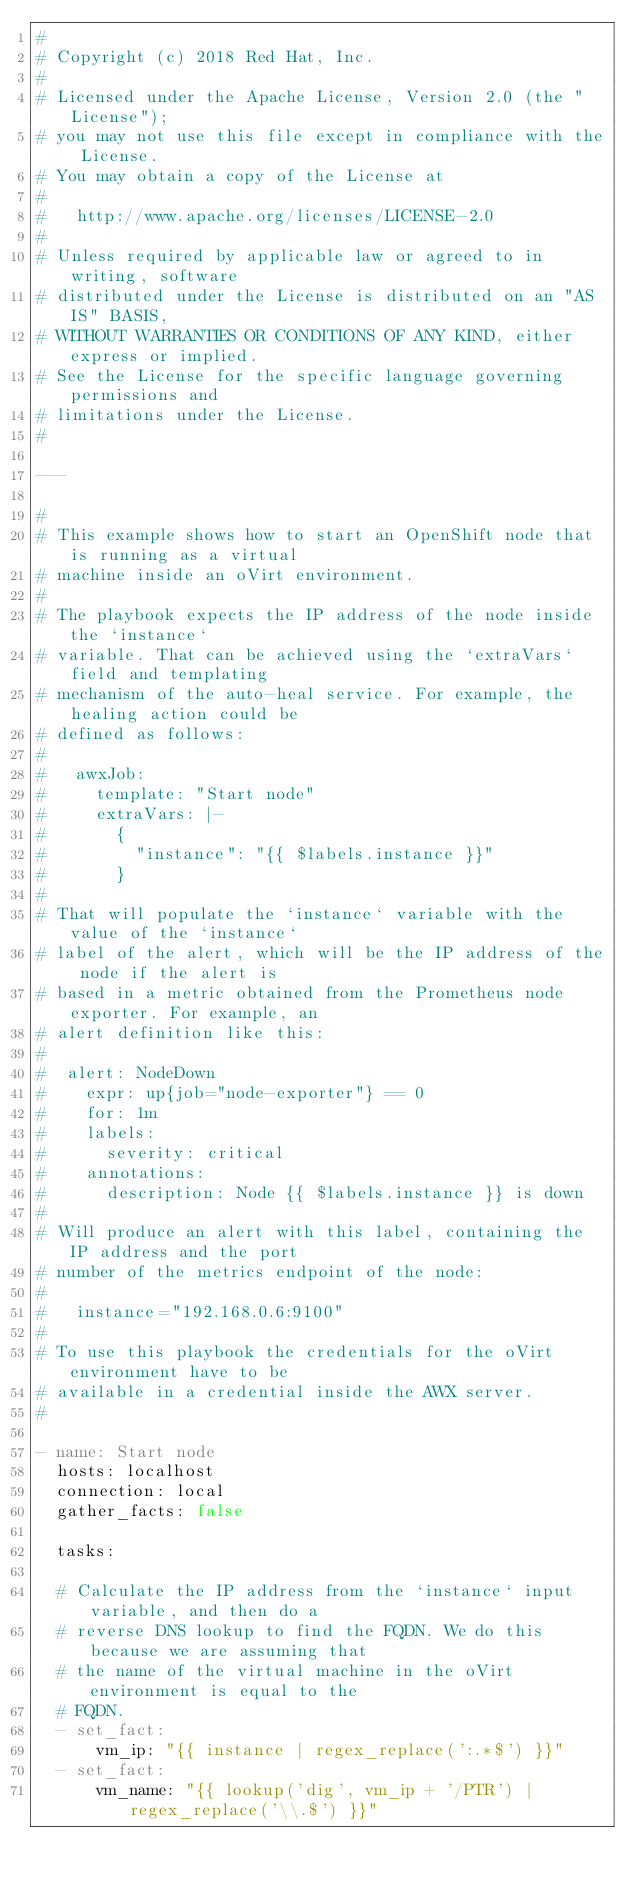Convert code to text. <code><loc_0><loc_0><loc_500><loc_500><_YAML_>#
# Copyright (c) 2018 Red Hat, Inc.
#
# Licensed under the Apache License, Version 2.0 (the "License");
# you may not use this file except in compliance with the License.
# You may obtain a copy of the License at
#
#   http://www.apache.org/licenses/LICENSE-2.0
#
# Unless required by applicable law or agreed to in writing, software
# distributed under the License is distributed on an "AS IS" BASIS,
# WITHOUT WARRANTIES OR CONDITIONS OF ANY KIND, either express or implied.
# See the License for the specific language governing permissions and
# limitations under the License.
#

---

#
# This example shows how to start an OpenShift node that is running as a virtual
# machine inside an oVirt environment.
#
# The playbook expects the IP address of the node inside the `instance`
# variable. That can be achieved using the `extraVars` field and templating
# mechanism of the auto-heal service. For example, the healing action could be
# defined as follows:
#
#   awxJob:
#     template: "Start node"
#     extraVars: |-
#       {
#         "instance": "{{ $labels.instance }}"
#       }
#
# That will populate the `instance` variable with the value of the `instance`
# label of the alert, which will be the IP address of the node if the alert is
# based in a metric obtained from the Prometheus node exporter. For example, an
# alert definition like this:
#
#  alert: NodeDown
#    expr: up{job="node-exporter"} == 0
#    for: 1m
#    labels:
#      severity: critical
#    annotations:
#      description: Node {{ $labels.instance }} is down
#
# Will produce an alert with this label, containing the IP address and the port
# number of the metrics endpoint of the node:
#
#   instance="192.168.0.6:9100"
#
# To use this playbook the credentials for the oVirt environment have to be
# available in a credential inside the AWX server.
#

- name: Start node
  hosts: localhost
  connection: local
  gather_facts: false

  tasks:

  # Calculate the IP address from the `instance` input variable, and then do a
  # reverse DNS lookup to find the FQDN. We do this because we are assuming that
  # the name of the virtual machine in the oVirt environment is equal to the
  # FQDN.
  - set_fact:
      vm_ip: "{{ instance | regex_replace(':.*$') }}"
  - set_fact:
      vm_name: "{{ lookup('dig', vm_ip + '/PTR') | regex_replace('\\.$') }}"
</code> 